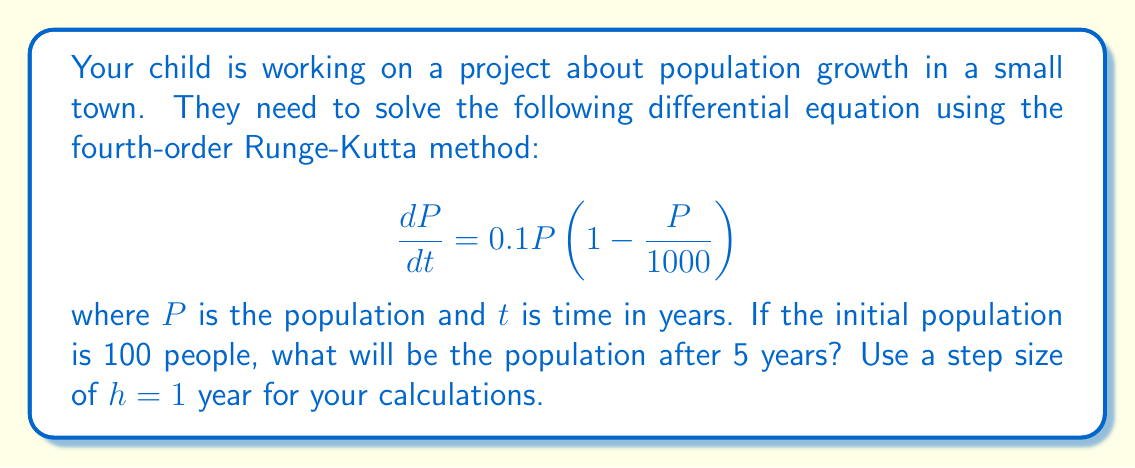Help me with this question. To solve this problem using the fourth-order Runge-Kutta method, we'll follow these steps:

1) The general form of the fourth-order Runge-Kutta method is:

   $$y_{n+1} = y_n + \frac{1}{6}(k_1 + 2k_2 + 2k_3 + k_4)$$

   where:
   $$k_1 = hf(t_n, y_n)$$
   $$k_2 = hf(t_n + \frac{h}{2}, y_n + \frac{k_1}{2})$$
   $$k_3 = hf(t_n + \frac{h}{2}, y_n + \frac{k_2}{2})$$
   $$k_4 = hf(t_n + h, y_n + k_3)$$

2) In our case, $f(t, P) = 0.1P(1 - \frac{P}{1000})$, $h = 1$, and $P_0 = 100$.

3) We need to calculate 5 steps (from year 0 to year 5). Let's do the first step in detail:

   For $n = 0$:
   $$k_1 = 1 \cdot 0.1 \cdot 100 \cdot (1 - \frac{100}{1000}) = 9$$
   $$k_2 = 1 \cdot 0.1 \cdot (100 + \frac{9}{2}) \cdot (1 - \frac{100 + \frac{9}{2}}{1000}) = 9.40995$$
   $$k_3 = 1 \cdot 0.1 \cdot (100 + \frac{9.40995}{2}) \cdot (1 - \frac{100 + \frac{9.40995}{2}}{1000}) = 9.43471$$
   $$k_4 = 1 \cdot 0.1 \cdot (100 + 9.43471) \cdot (1 - \frac{100 + 9.43471}{1000}) = 9.86943$$

   $$P_1 = 100 + \frac{1}{6}(9 + 2(9.40995) + 2(9.43471) + 9.86943) = 109.45$$

4) Repeating this process for the next 4 years:

   Year 2: $P_2 = 119.76$
   Year 3: $P_3 = 130.88$
   Year 4: $P_4 = 142.75$
   Year 5: $P_5 = 155.31$

Therefore, after 5 years, the population will be approximately 155 people.
Answer: The population after 5 years will be approximately 155 people. 